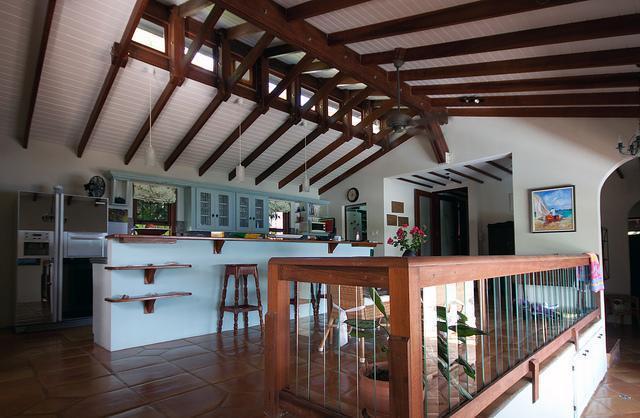How many chefs are there?
Give a very brief answer. 0. 